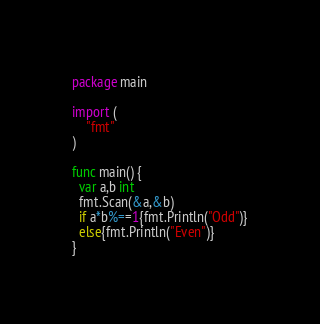Convert code to text. <code><loc_0><loc_0><loc_500><loc_500><_Go_>package main

import (
    "fmt"
)

func main() {
  var a,b int
  fmt.Scan(&a,&b)
  if a*b%==1{fmt.Println("Odd")}
  else{fmt.Println("Even")}
}

</code> 